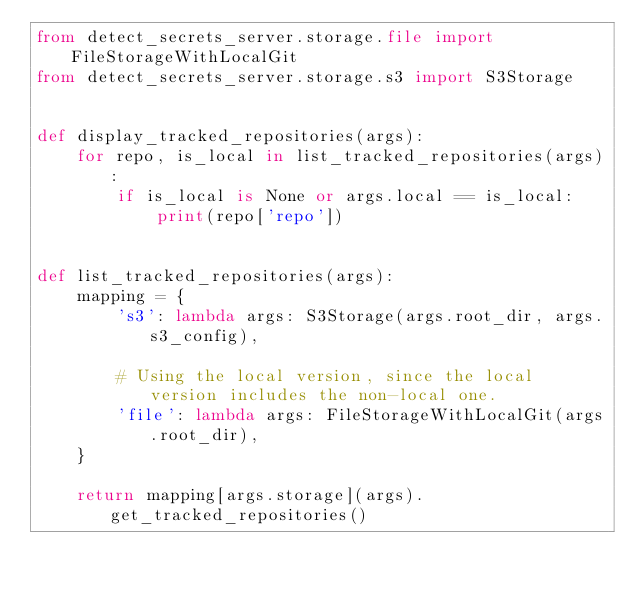Convert code to text. <code><loc_0><loc_0><loc_500><loc_500><_Python_>from detect_secrets_server.storage.file import FileStorageWithLocalGit
from detect_secrets_server.storage.s3 import S3Storage


def display_tracked_repositories(args):
    for repo, is_local in list_tracked_repositories(args):
        if is_local is None or args.local == is_local:
            print(repo['repo'])


def list_tracked_repositories(args):
    mapping = {
        's3': lambda args: S3Storage(args.root_dir, args.s3_config),

        # Using the local version, since the local version includes the non-local one.
        'file': lambda args: FileStorageWithLocalGit(args.root_dir),
    }

    return mapping[args.storage](args).get_tracked_repositories()
</code> 